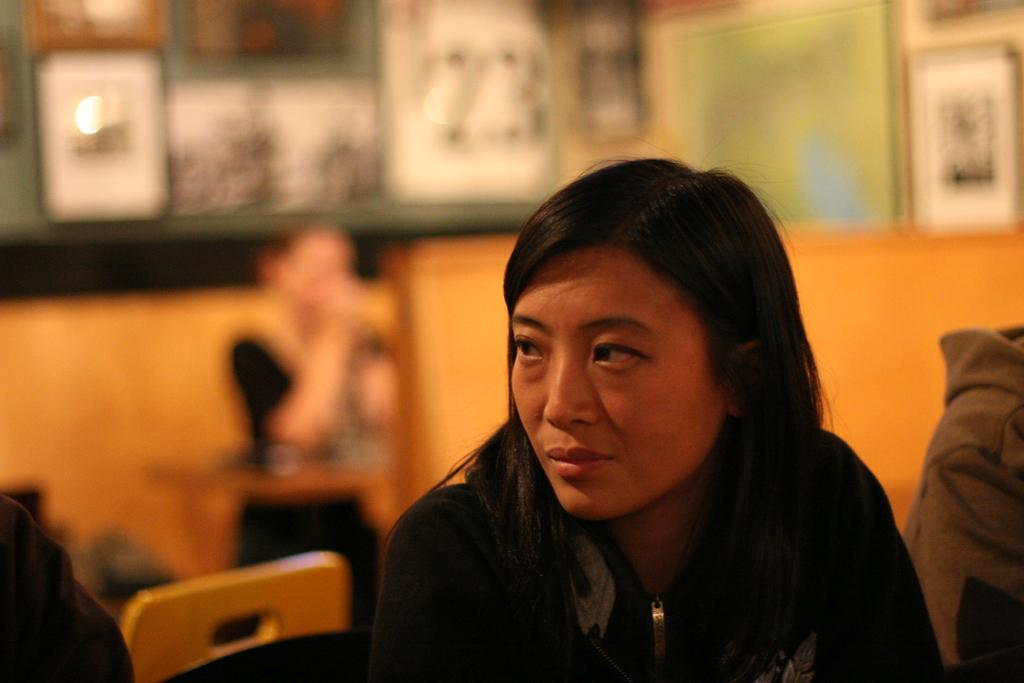What is the main subject of the image? The main subject of the image is a group of people. What colors are the people wearing? The people are wearing black and grey color dresses. What can be seen on the wall in the image? There are frames on the wall in the image. How would you describe the background of the image? The background of the image is blurred. What type of plough is being used by the people in the image? There is no plough present in the image; it features a group of people wearing black and grey color dresses. How does the sister in the image contribute to the rhythm of the scene? There is no mention of a sister or rhythm in the image, as it only features a group of people wearing black and grey color dresses and frames on the wall. 